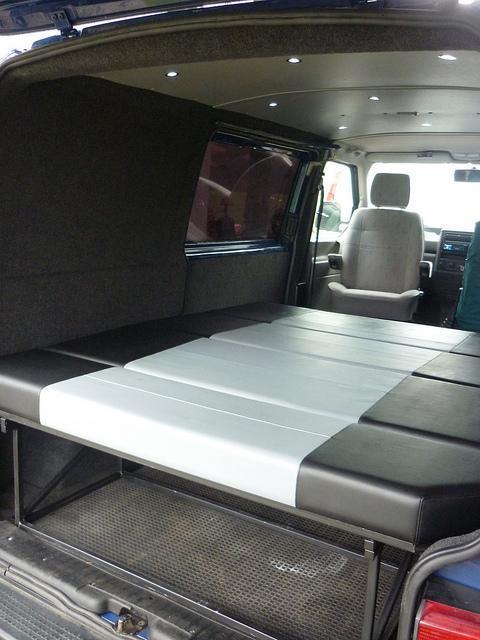How many seats are there?
Give a very brief answer. 1. How many chairs are visible?
Give a very brief answer. 1. 